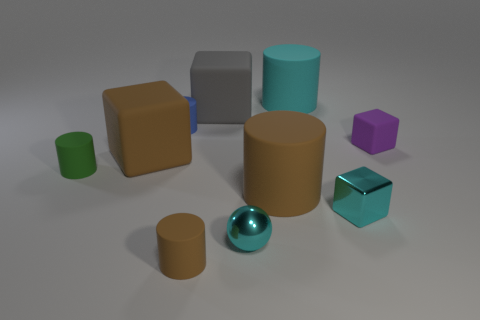Can you guess the purpose of this arrangement? Is it random or intentional? This arrangement appears to be a deliberate composition, likely created for the purpose of visual demonstration or perhaps as a test render to showcase different shapes and materials in 3D modeling software. Each object seems to have a distinct size, shape, and color, which could be used to test lighting, shading, and reflection. 